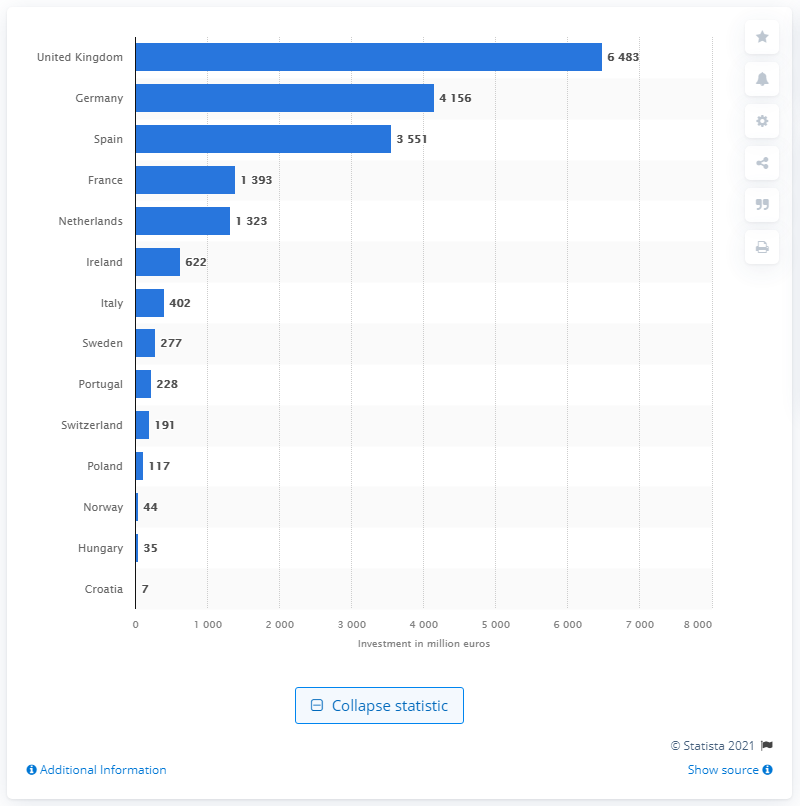Point out several critical features in this image. In 2018, the amount of investment in the hotel sector in the UK was 6,483. According to data from 2018, Germany had the highest level of hotel investment among all countries. 